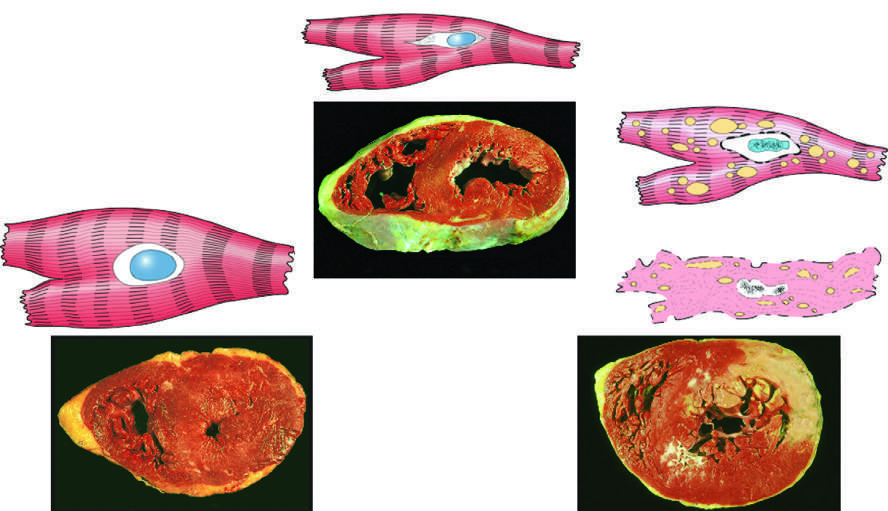what is due to enzyme loss after cell death?
Answer the question using a single word or phrase. Failure to stain 